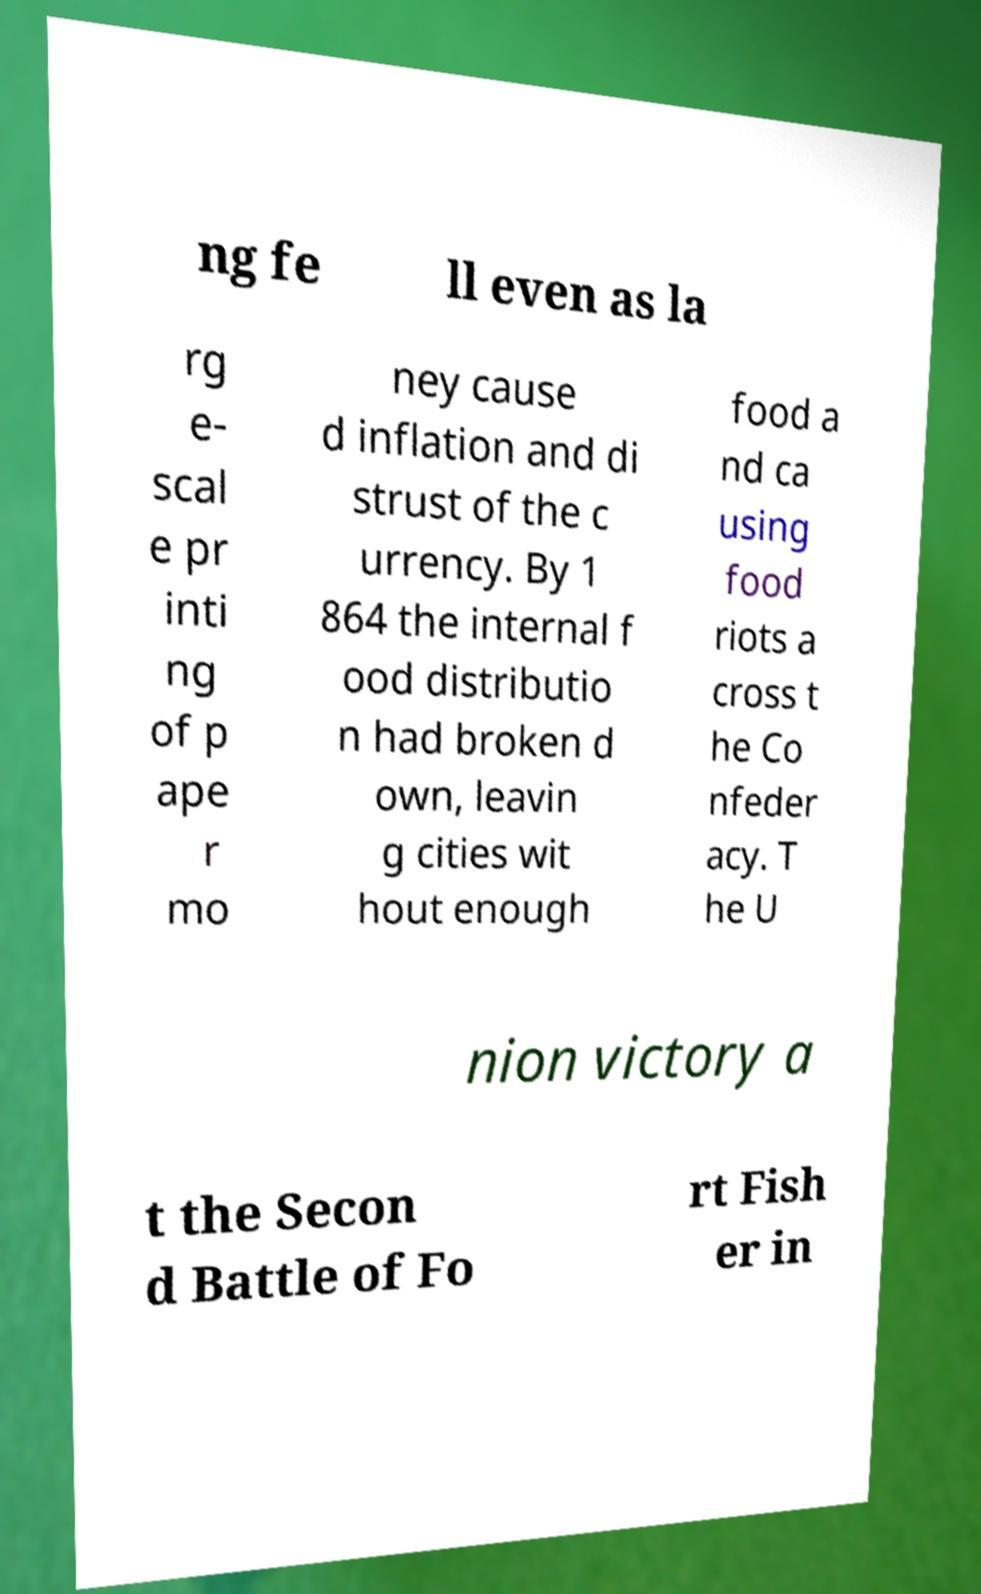I need the written content from this picture converted into text. Can you do that? ng fe ll even as la rg e- scal e pr inti ng of p ape r mo ney cause d inflation and di strust of the c urrency. By 1 864 the internal f ood distributio n had broken d own, leavin g cities wit hout enough food a nd ca using food riots a cross t he Co nfeder acy. T he U nion victory a t the Secon d Battle of Fo rt Fish er in 